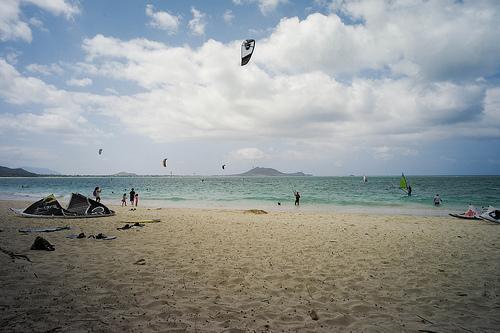How many animals are pictured here?
Give a very brief answer. 0. How many people are wearing black?
Give a very brief answer. 2. 